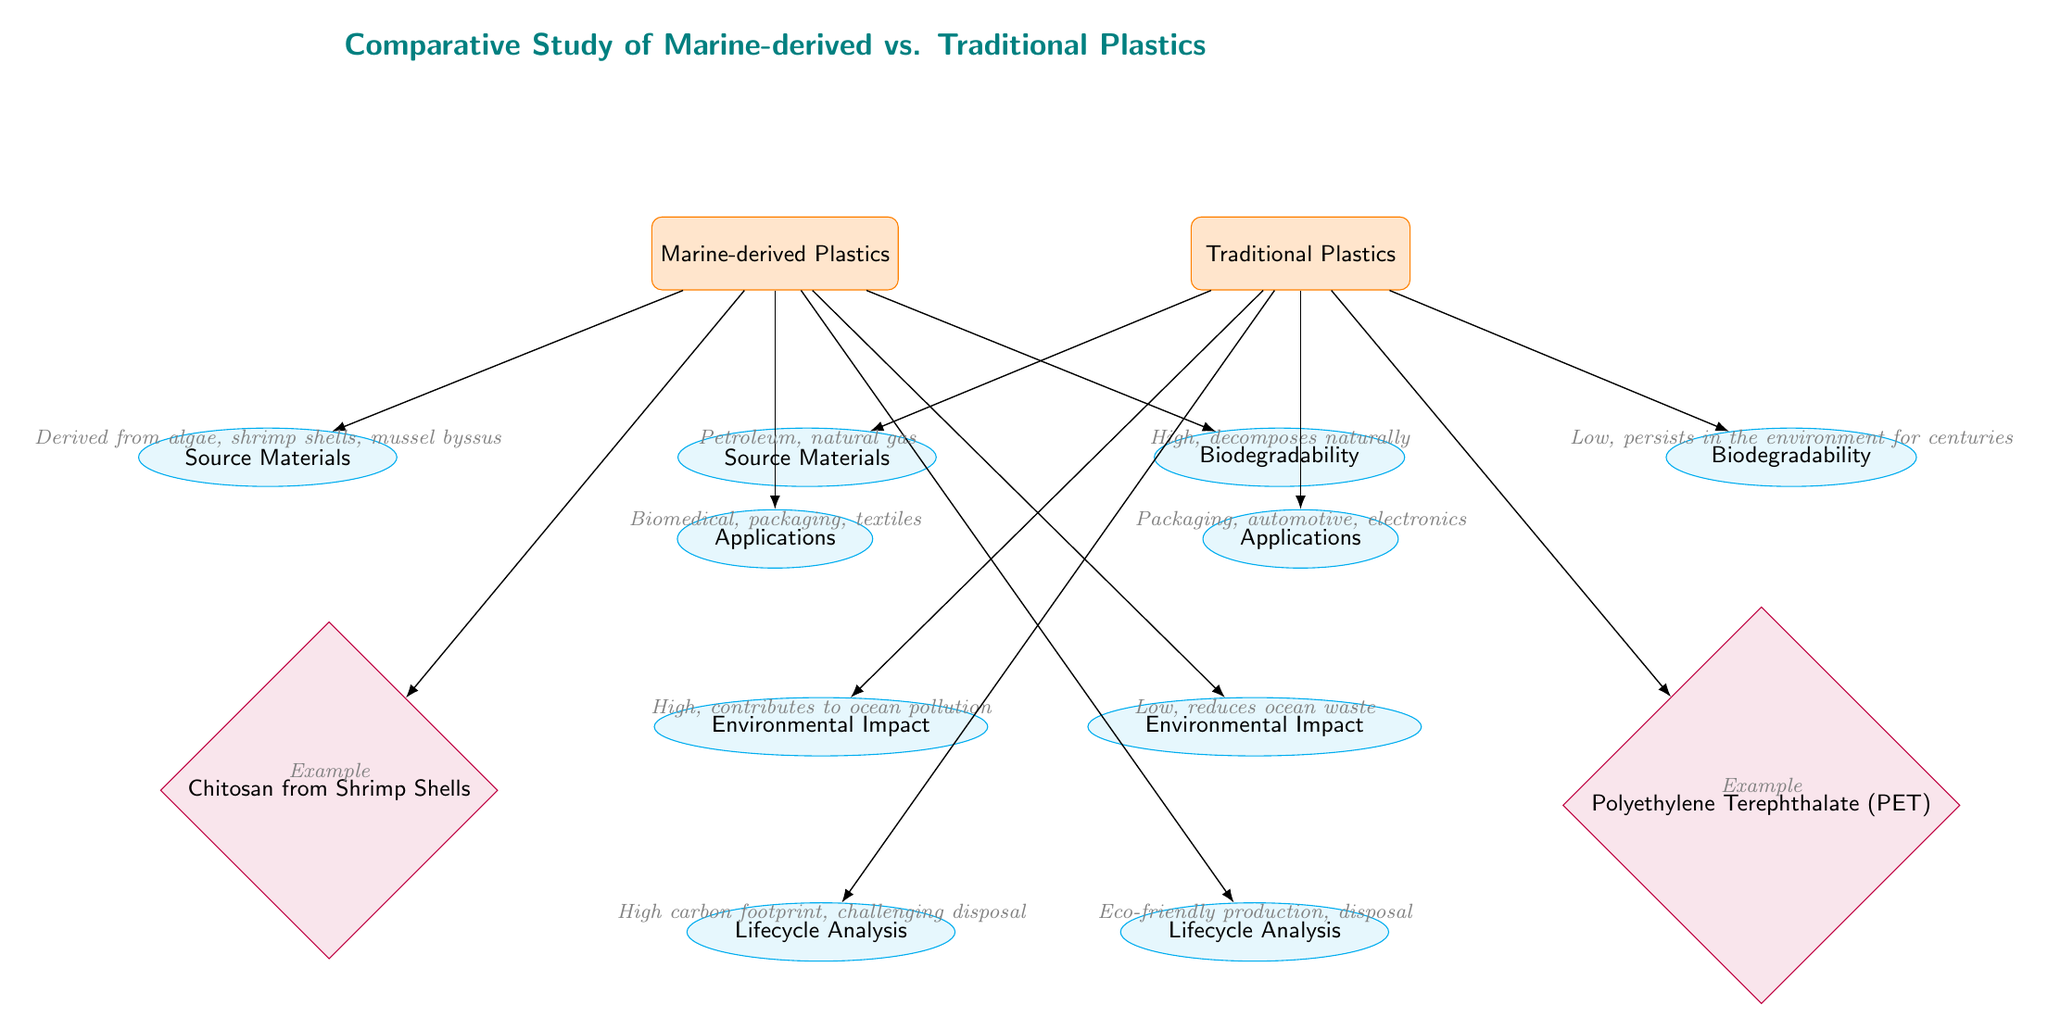What is the source material for marine-derived plastics? The diagram specifies that marine-derived plastics are derived from algae, shrimp shells, and mussel byssus. This information is found under the "Source Materials" node linked to "Marine-derived Plastics."
Answer: Algae, shrimp shells, mussel byssus What is the biodegradability of traditional plastics? According to the diagram, traditional plastics have low biodegradability and persist in the environment for centuries, indicated in the "Biodegradability" node connected to "Traditional Plastics."
Answer: Low What application is listed for marine-derived plastics? The diagram indicates that marine-derived plastics can be used for biomedical, packaging, and textiles, which is found under the "Applications" node related to "Marine-derived Plastics."
Answer: Biomedical, packaging, textiles What is the environmental impact of traditional plastics? The diagram states that traditional plastics have a high environmental impact, contributing to ocean pollution, as detailed in the "Environmental Impact" node under "Traditional Plastics."
Answer: High Which example is given for traditional plastics? The diagram names Polyethylene Terephthalate (PET) as the example for traditional plastics, which is illustrated under the "Applications" subcategory of "Traditional Plastics."
Answer: Polyethylene Terephthalate (PET) How does the lifecycle analysis of marine-derived plastics compare to traditional plastics? The diagram demonstrates that marine-derived plastics have an eco-friendly production and disposal lifecycle, while traditional plastics have a high carbon footprint and challenging disposal. This information is captured in the "Lifecycle Analysis" nodes under both categories.
Answer: Eco-friendly vs. High carbon footprint What is the main advantage of marine-derived plastics in terms of biodegradability? The diagram indicates that marine-derived plastics have high biodegradability, decomposing naturally, which is contrasted with the low biodegradability of traditional plastics. This information is located in the "Biodegradability" nodes of each type.
Answer: High How many examples of materials are given for marine-derived plastics? The diagram provides one specific example (Chitosan from Shrimp Shells) in the "Examples" section for marine-derived plastics. This indicates the focus on that singular example rather than multiple materials.
Answer: One What common source material do both marine-derived and traditional plastics have? The documents indicate that the commonality is that traditional plastics derive from petroleum and natural gas, while marine-derived come from marine organisms. This question requires examining both source material nodes.
Answer: None (they are different sources) How does the environmental impact of marine-derived plastics compare to that of traditional plastics? The diagram shows that marine-derived plastics have a low environmental impact, as opposed to traditional plastics which have a high environmental impact. This contrasts the two nodes under "Environmental Impact."
Answer: Low vs. High 